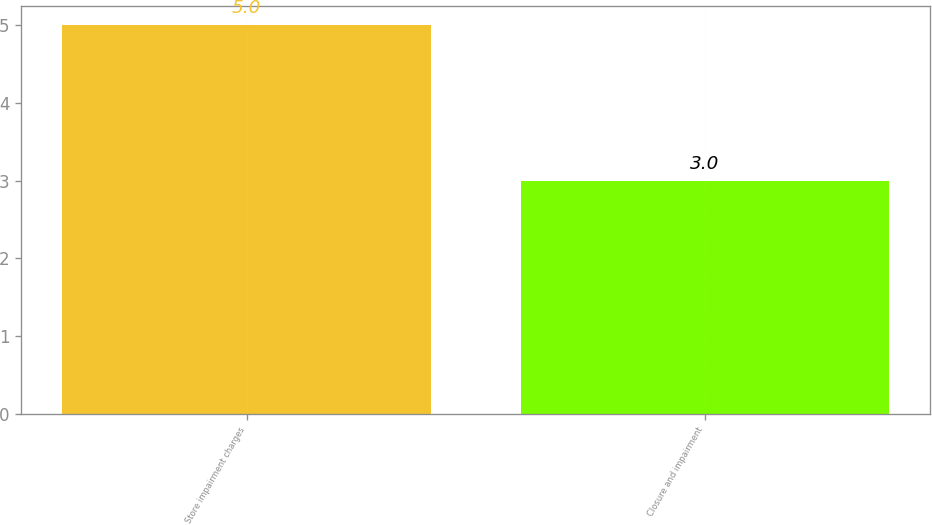Convert chart. <chart><loc_0><loc_0><loc_500><loc_500><bar_chart><fcel>Store impairment charges<fcel>Closure and impairment<nl><fcel>5<fcel>3<nl></chart> 